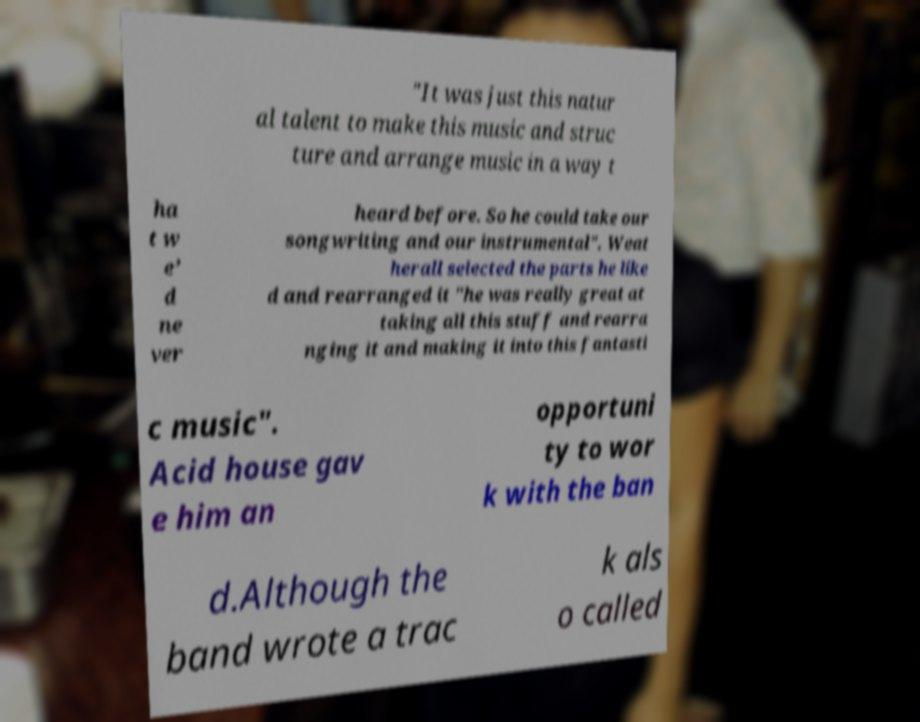What messages or text are displayed in this image? I need them in a readable, typed format. "It was just this natur al talent to make this music and struc ture and arrange music in a way t ha t w e’ d ne ver heard before. So he could take our songwriting and our instrumental". Weat herall selected the parts he like d and rearranged it "he was really great at taking all this stuff and rearra nging it and making it into this fantasti c music". Acid house gav e him an opportuni ty to wor k with the ban d.Although the band wrote a trac k als o called 